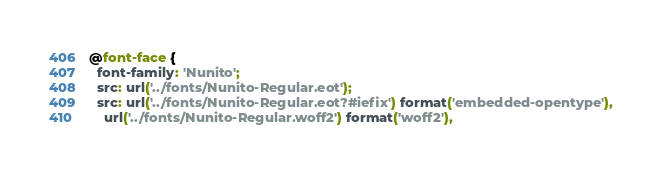Convert code to text. <code><loc_0><loc_0><loc_500><loc_500><_CSS_>@font-face {
  font-family: 'Nunito';
  src: url('../fonts/Nunito-Regular.eot');
  src: url('../fonts/Nunito-Regular.eot?#iefix') format('embedded-opentype'),
    url('../fonts/Nunito-Regular.woff2') format('woff2'),</code> 